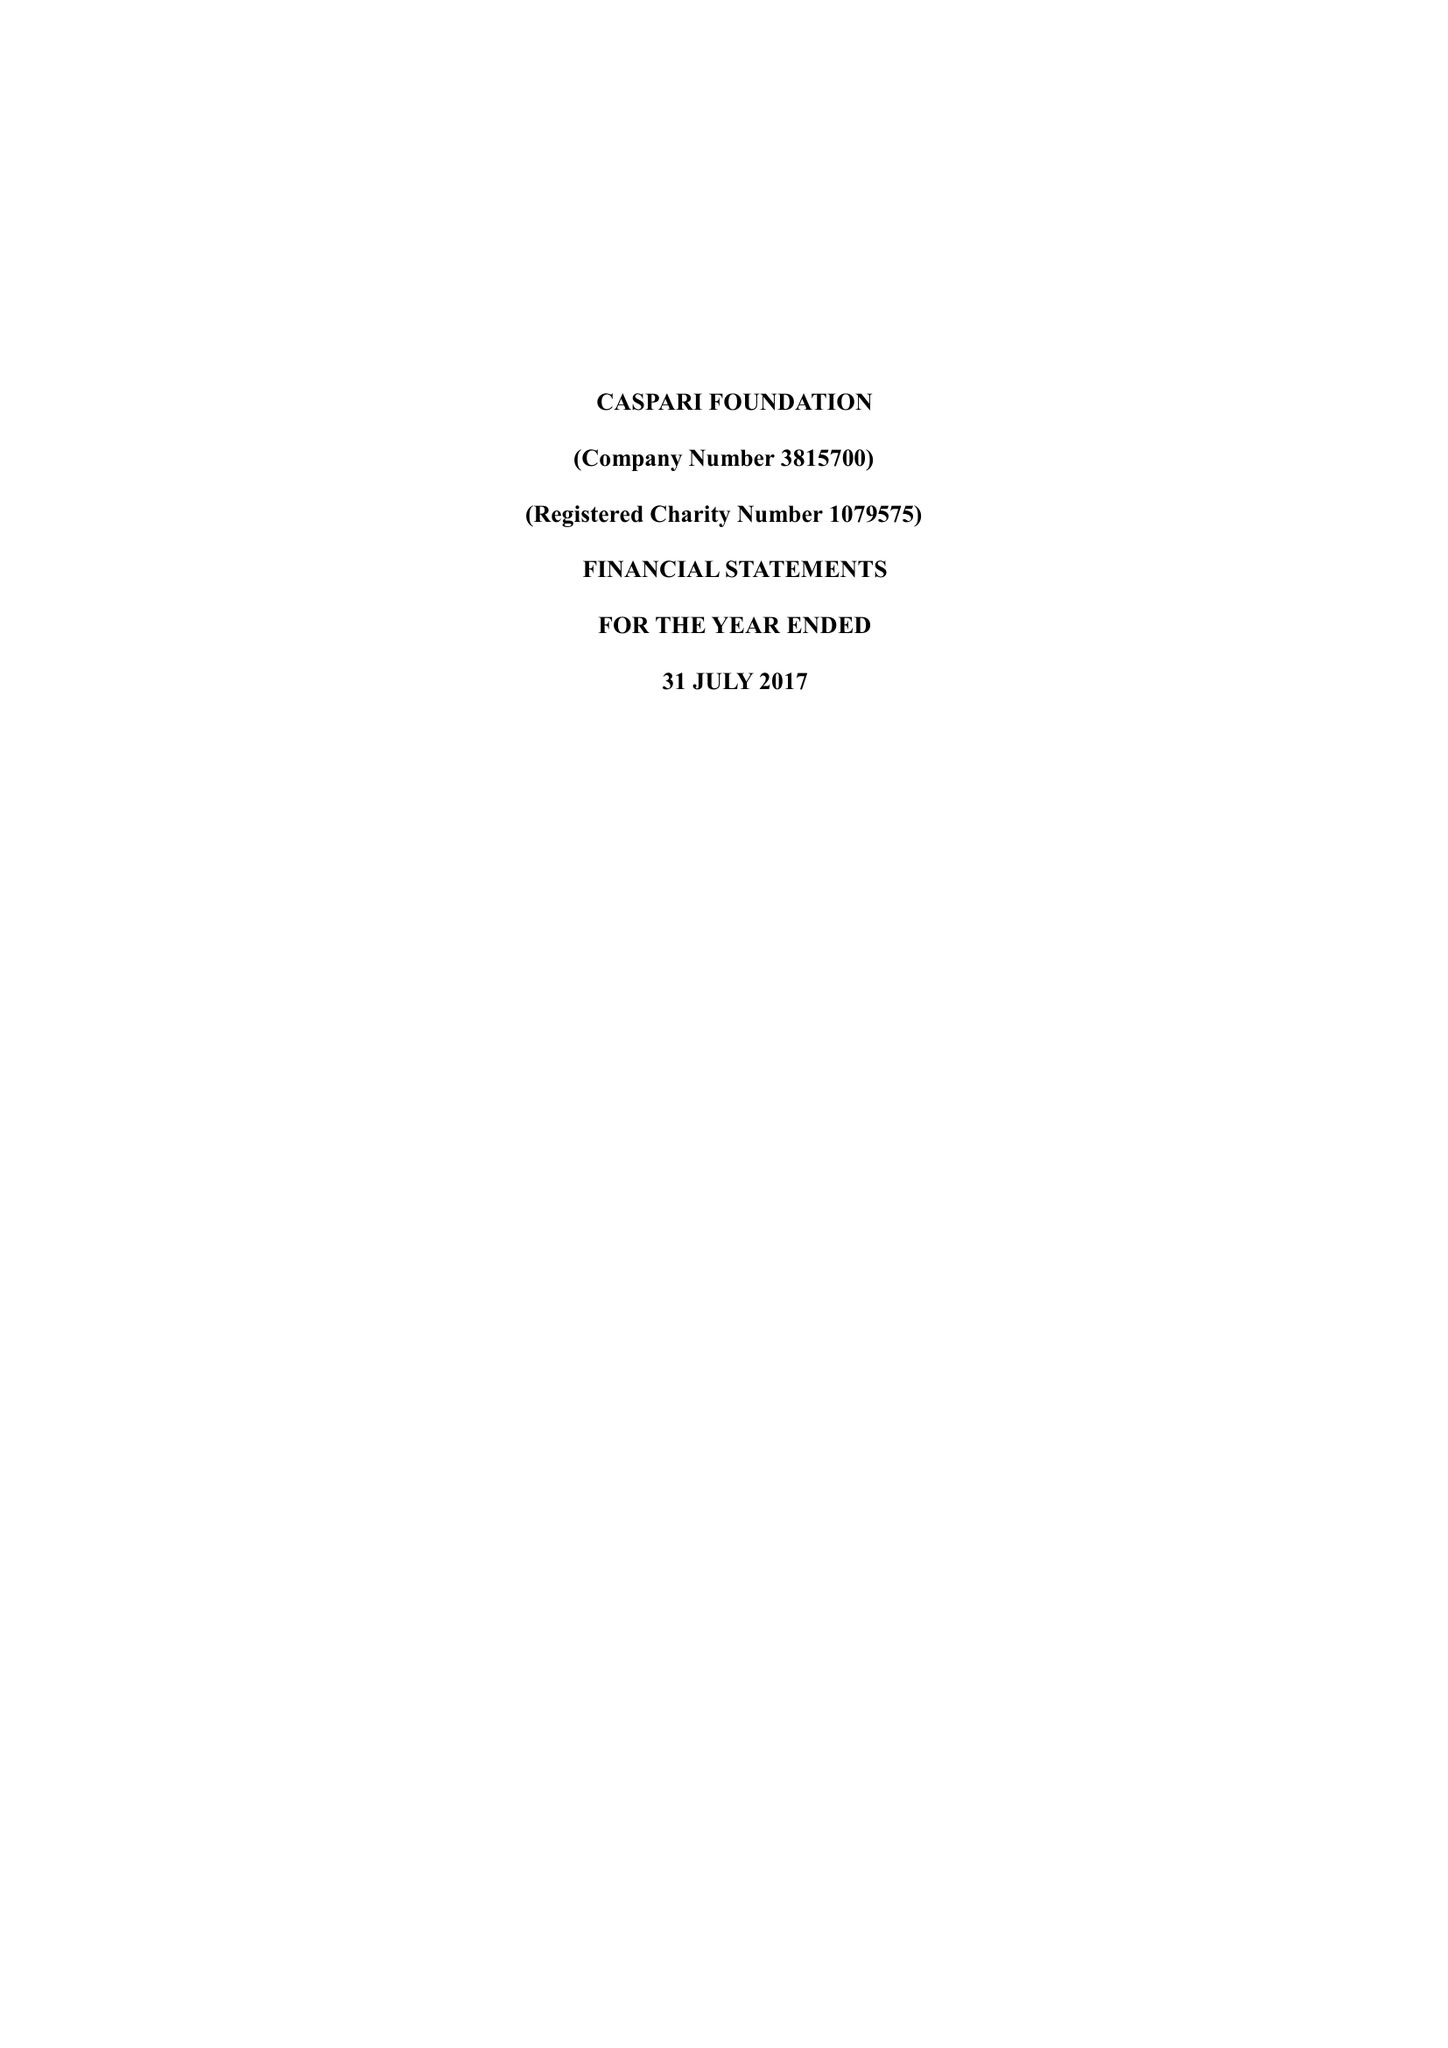What is the value for the report_date?
Answer the question using a single word or phrase. 2017-07-31 